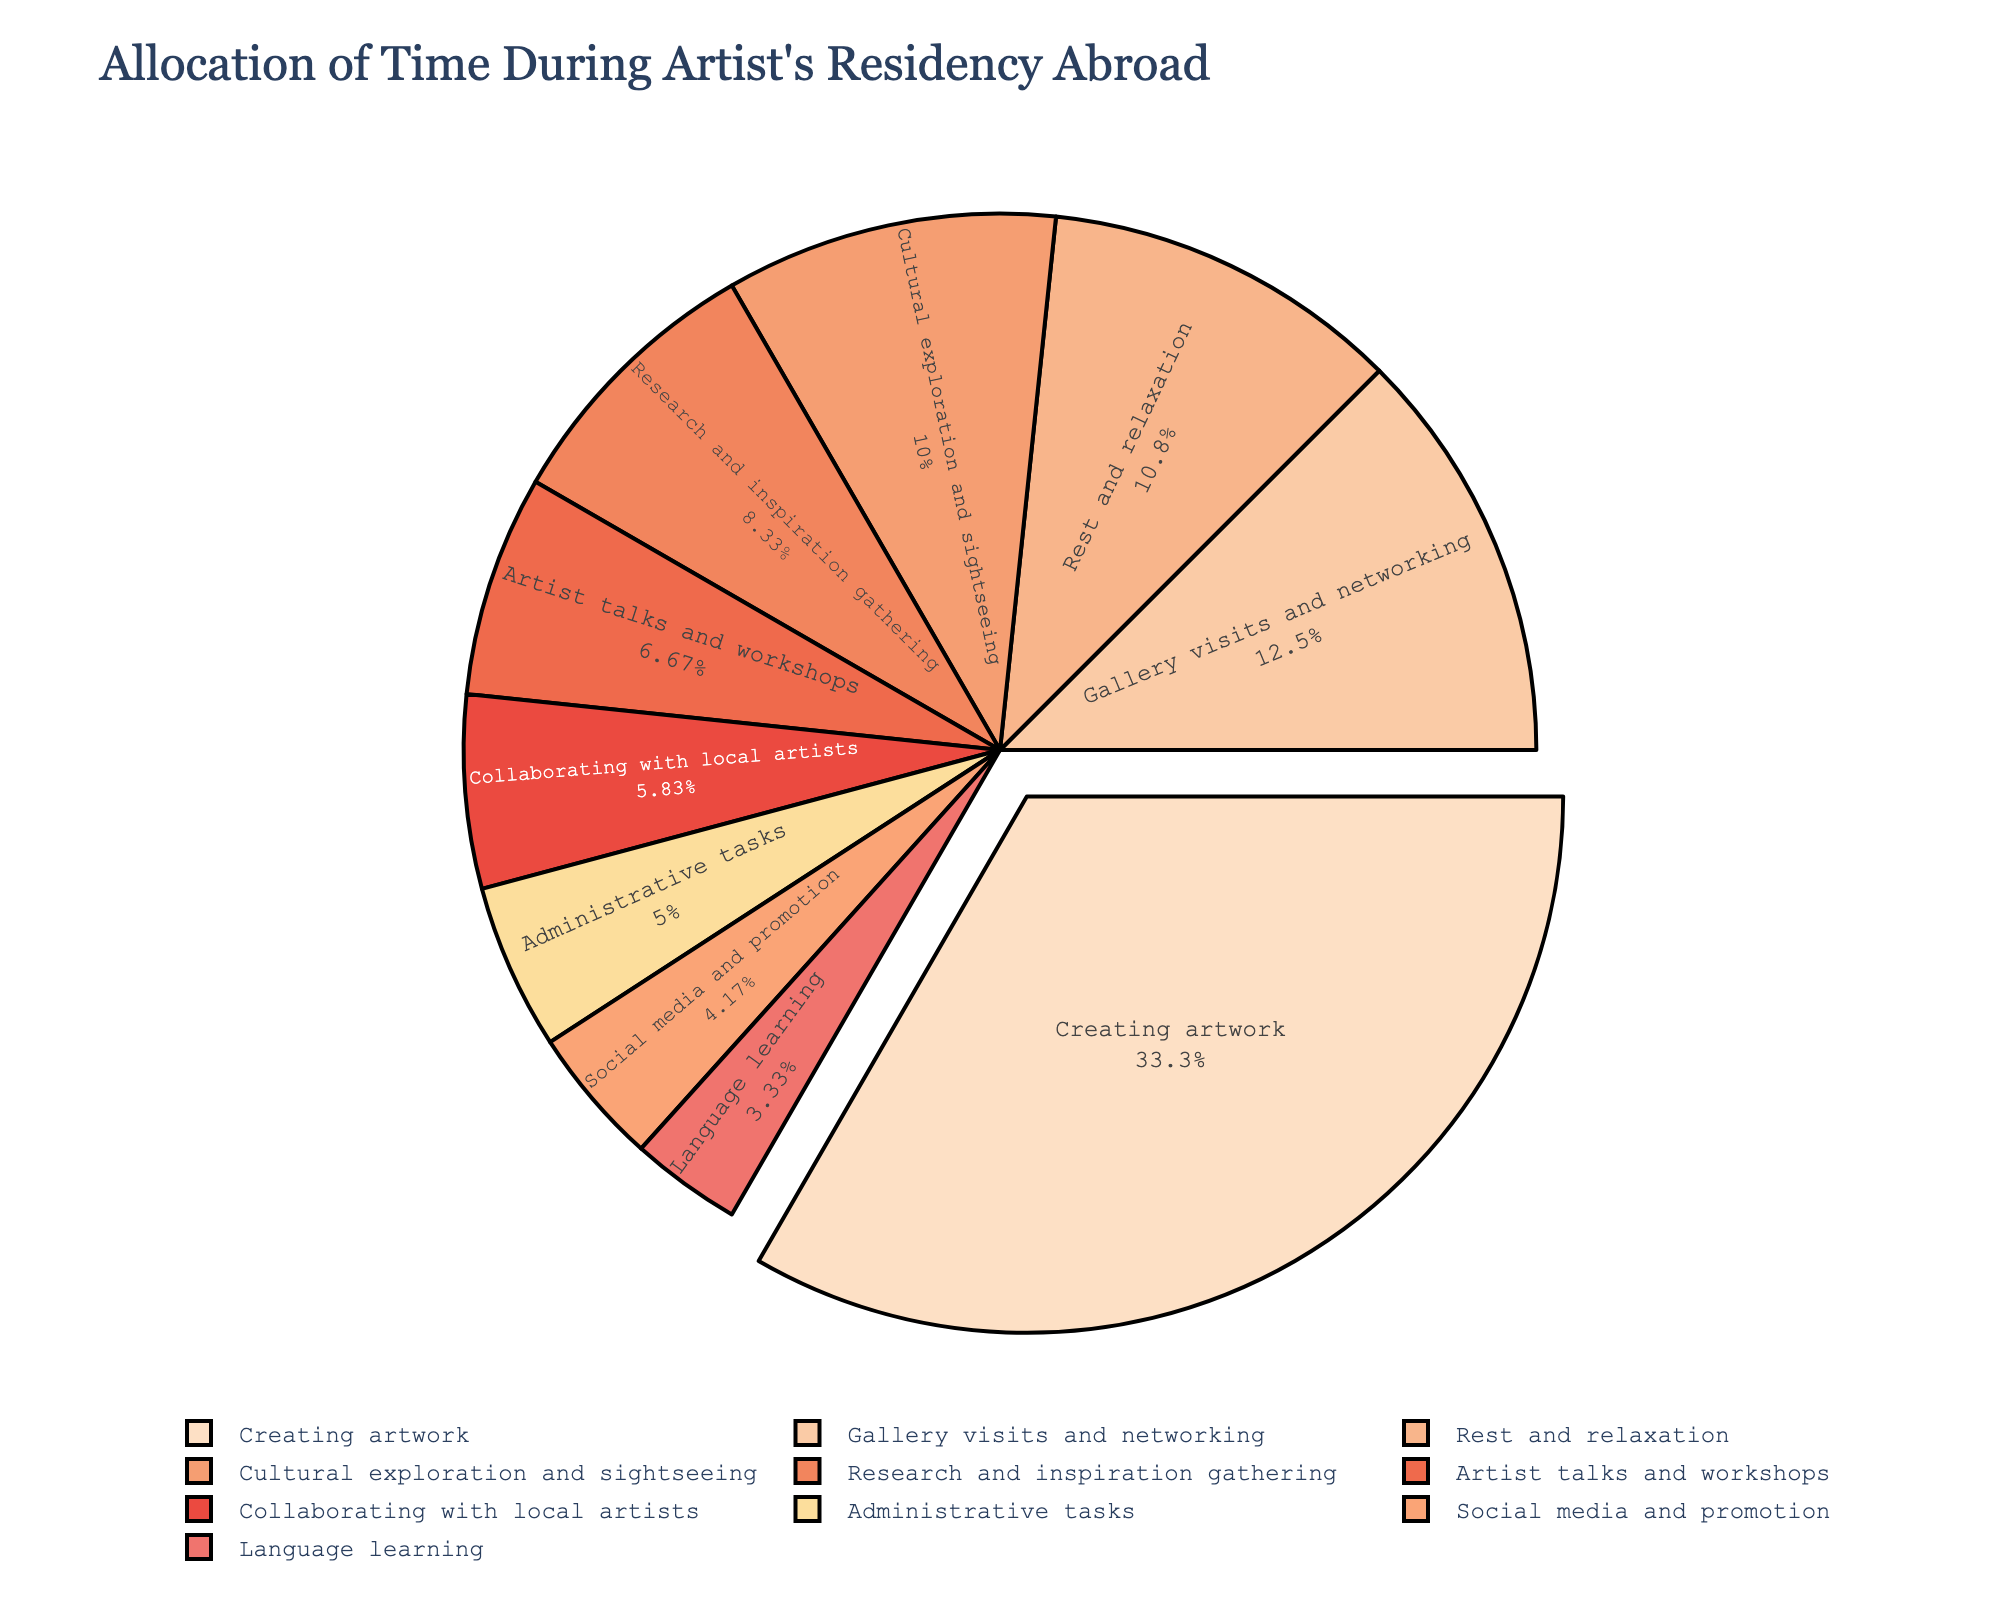How many more hours are spent on creating artwork compared to gallery visits and networking? Creating artwork takes 40 hours and gallery visits and networking take 15 hours. The difference is 40 - 15 = 25 hours.
Answer: 25 Which activity occupies the smallest slice of the pie chart? Based on the hours allocated to each activity, language learning has 4 hours, which is the smallest number.
Answer: Language learning What percentage of time is spent on rest and relaxation? Rest and relaxation involve 13 hours out of the total sum of all hours. Sum = 40 + 15 + 12 + 8 + 6 + 5 + 10 + 7 + 4 + 13 = 120 hours. The percentage is (13 / 120) * 100 ≈ 10.83%.
Answer: Approximately 10.83% Is more time allocated to creating artwork or to collaborating with local artists and attending artist talks and workshops combined? Creating artwork takes 40 hours. Collaborating with local artists takes 7 hours, and artist talks and workshops take 8 hours. Combined, this is 7 + 8 = 15 hours, which is less than 40 hours.
Answer: Creating artwork Does cultural exploration and sightseeing take up more time than research and inspiration gathering? Cultural exploration and sightseeing take 12 hours, whereas research and inspiration gathering takes 10 hours. 12 is greater than 10.
Answer: Yes What is the combined percentage of time spent on social media and promotion, and administrative tasks? Social media and promotion take 5 hours, and administrative tasks take 6 hours. Combined, this is 5 + 6 = 11 hours. The total hours are 120. The percentage is (11 / 120) * 100 ≈ 9.17%.
Answer: Approximately 9.17% Which activity, represented by a lighter shade in the color palette, has a higher number of hours: research and inspiration gathering or artist talks and workshops? Both research and inspiration gathering (10 hours) and artist talks and workshops (8 hours) have lighter shades in the color palette. Research and inspiration gathering has more hours than artist talks and workshops.
Answer: Research and inspiration gathering What is the median value of hours spent on all activities? Ordered values: 4, 5, 6, 7, 8, 10, 12, 13, 15, 40. The median value in this ordered list is the average of the 5th and 6th values. (8 + 10) / 2 = 18 / 2 = 9
Answer: 9 How many activities take up more than 10 hours each? Creating artwork (40 hours), rest and relaxation (13 hours), cultural exploration and sightseeing (12 hours), and gallery visits and networking (15 hours) each take more than 10 hours.
Answer: 4 What is the difference in the percentage of hours spent on administrative tasks compared to language learning? Administrative tasks take 6 hours, and language learning takes 4 hours. The total hours are 120. The percentages are (6 / 120) * 100 = 5% and (4 / 120) * 100 ≈ 3.33%. The difference is 5% - 3.33% ≈ 1.67%.
Answer: Approximately 1.67% 